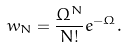<formula> <loc_0><loc_0><loc_500><loc_500>w _ { N } = \frac { \Omega ^ { N } } { N ! } e ^ { - \Omega } .</formula> 